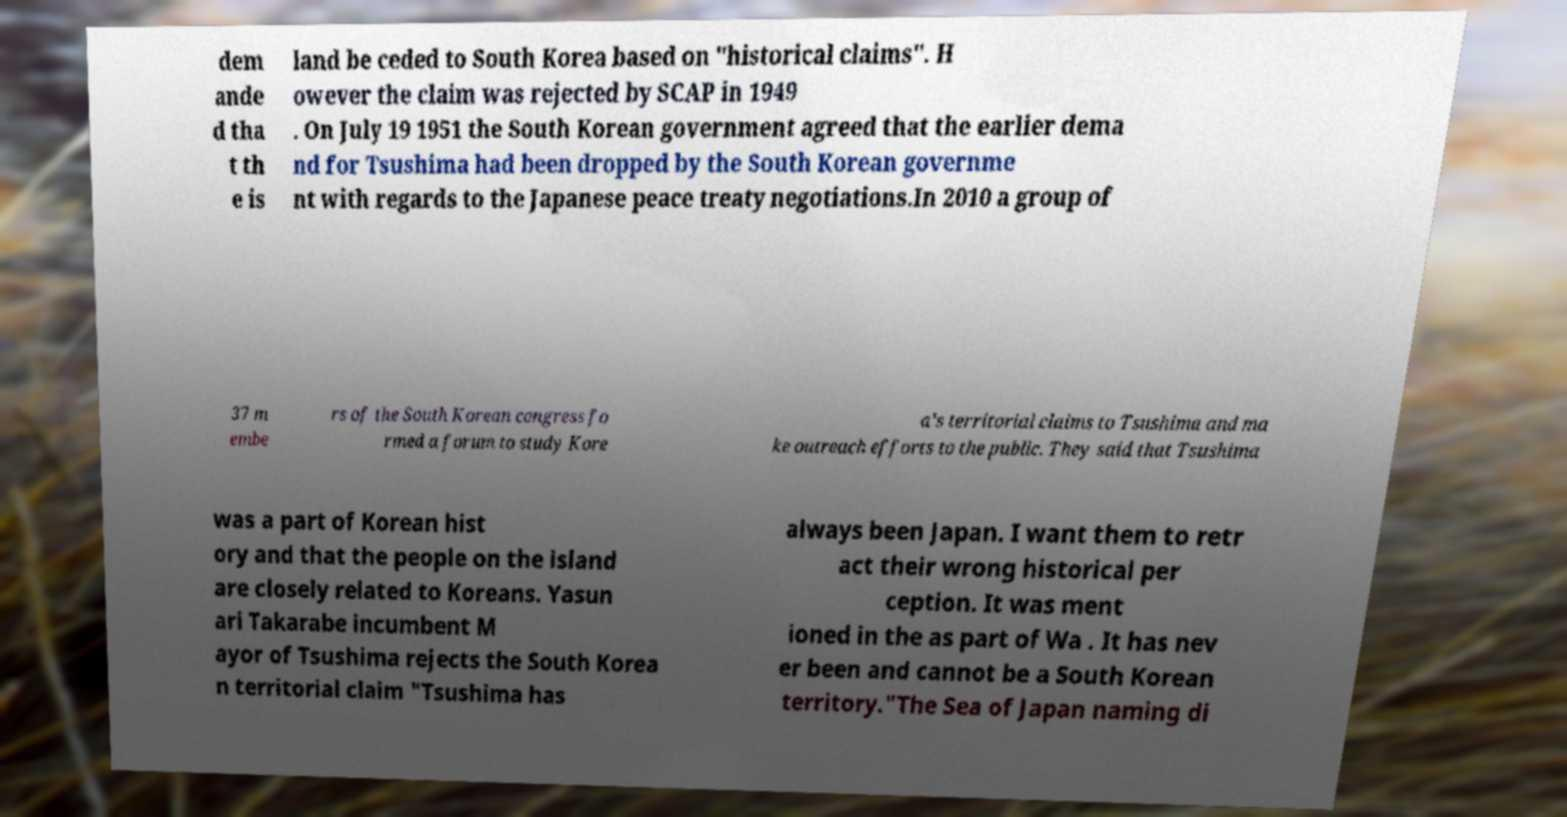I need the written content from this picture converted into text. Can you do that? dem ande d tha t th e is land be ceded to South Korea based on "historical claims". H owever the claim was rejected by SCAP in 1949 . On July 19 1951 the South Korean government agreed that the earlier dema nd for Tsushima had been dropped by the South Korean governme nt with regards to the Japanese peace treaty negotiations.In 2010 a group of 37 m embe rs of the South Korean congress fo rmed a forum to study Kore a's territorial claims to Tsushima and ma ke outreach efforts to the public. They said that Tsushima was a part of Korean hist ory and that the people on the island are closely related to Koreans. Yasun ari Takarabe incumbent M ayor of Tsushima rejects the South Korea n territorial claim "Tsushima has always been Japan. I want them to retr act their wrong historical per ception. It was ment ioned in the as part of Wa . It has nev er been and cannot be a South Korean territory."The Sea of Japan naming di 